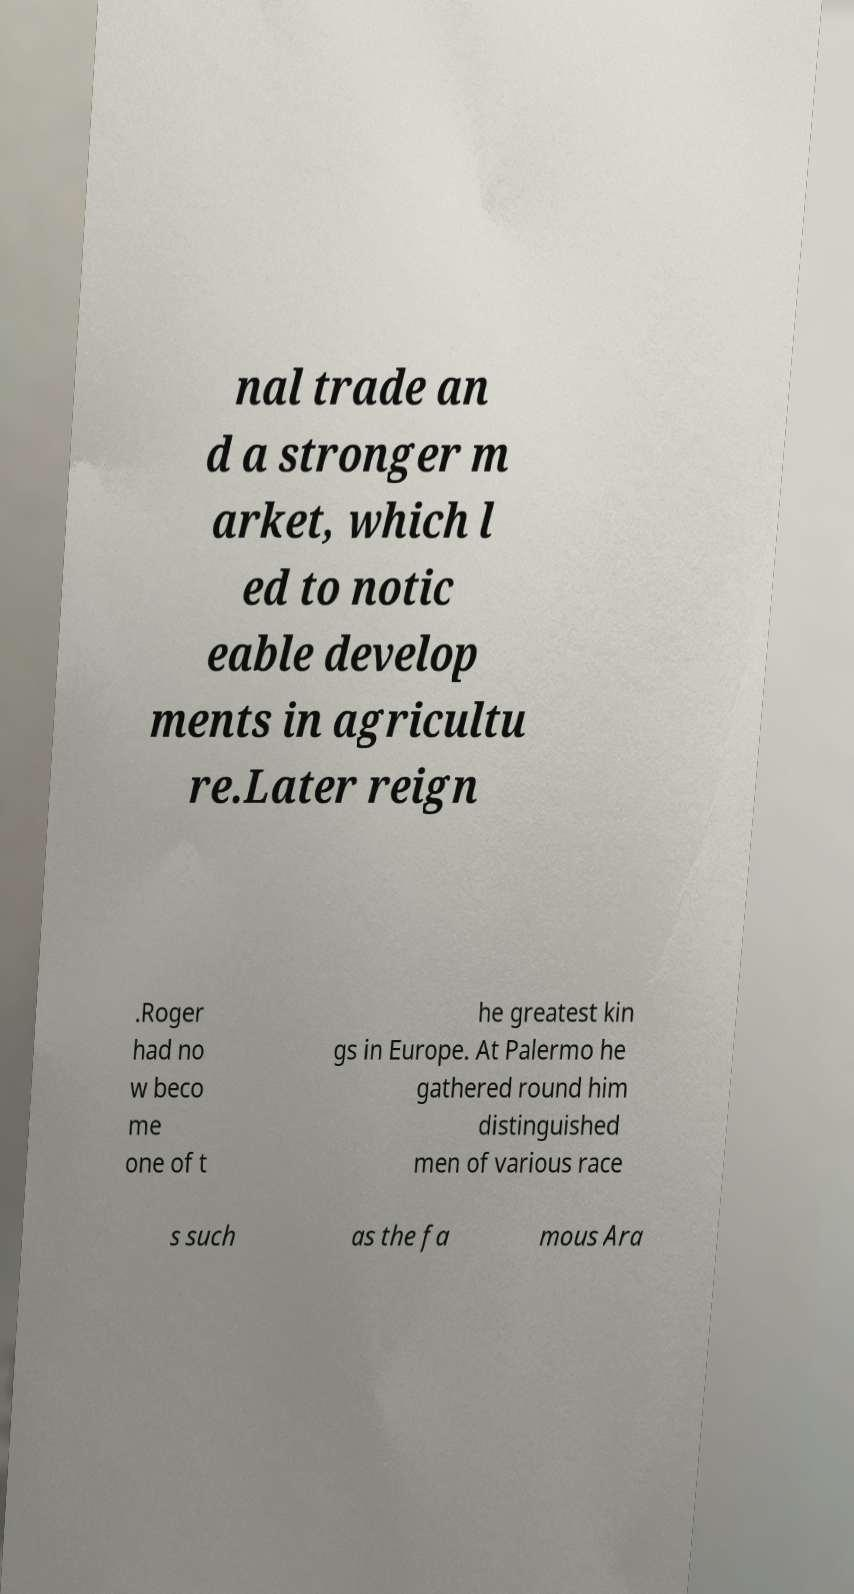Could you assist in decoding the text presented in this image and type it out clearly? nal trade an d a stronger m arket, which l ed to notic eable develop ments in agricultu re.Later reign .Roger had no w beco me one of t he greatest kin gs in Europe. At Palermo he gathered round him distinguished men of various race s such as the fa mous Ara 